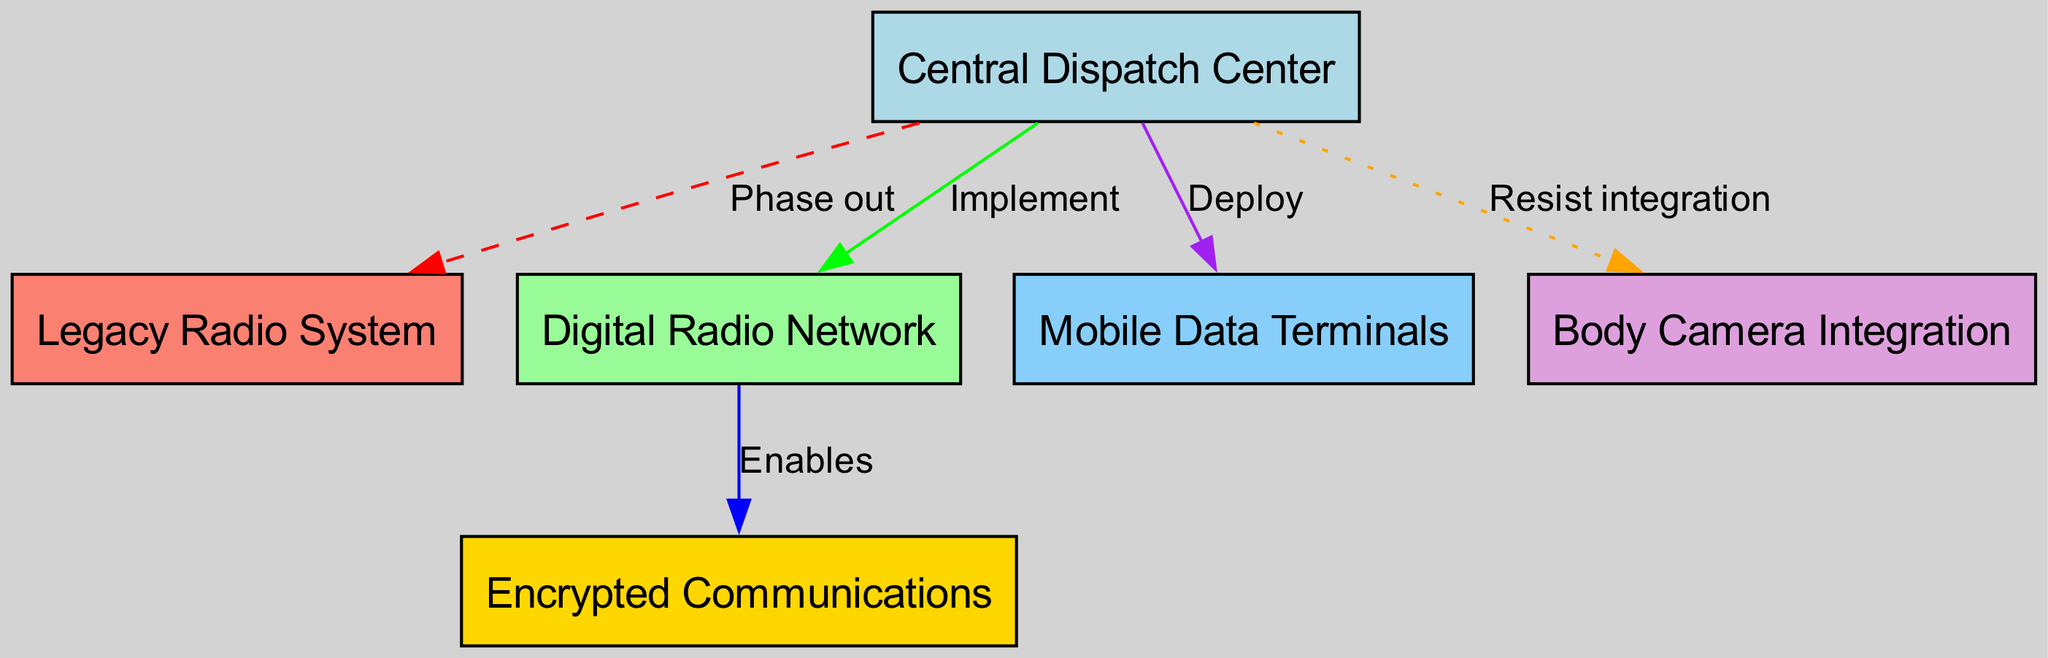What is the label of the node from the dispatch center that is being phased out? The diagram indicates that the dispatch center is connected to the legacy radio system, labeled as "Phase out." Thus, the node being phased out is the legacy radio system.
Answer: Legacy Radio System How many nodes are present in the diagram? By counting the nodes listed in the diagram, we find there are a total of six nodes: Central Dispatch Center, Legacy Radio System, Digital Radio Network, Encrypted Communications, Mobile Data Terminals, and Body Camera Integration.
Answer: 6 What is the relationship between the digital radio and encrypted communications? The diagram shows an edge labeled "Enables" directly connecting the digital radio network to encrypted communications, indicating that the digital radio network enables the encrypted communications.
Answer: Enables What is the primary action taken with the mobile data terminals? The action taken regarding the mobile data terminals, as indicated by the edge from the dispatch center, is labeled "Deploy." Therefore, the primary action is to deploy the mobile data terminals.
Answer: Deploy Which system is indicated to have resistance towards integration? The diagram specifies a connection from the dispatch center to body camera integration labeled "Resist integration," indicating the system that is facing resistance is the body camera integration.
Answer: Body Camera Integration What color represents the digital radio network in the diagram? Looking at the node colors described, the digital radio network is represented in pale green.
Answer: Pale Green How many edges are in the diagram? By examining the edges detailed in the diagram, there are five connections in total: phase out to legacy radio, implement to digital radio, enables to encrypted communications, deploy to mobile data, and resist integration to body cams.
Answer: 5 Which node is directly connected to both the digital radio network and mobile data terminals? The dispatch center is the only node that directly connects to the digital radio network (through "Implement") and the mobile data terminals (through "Deploy").
Answer: Central Dispatch Center What is the significance of the edge labeled "Phase out"? This edge indicates that the legacy radio system will be withdrawn, signifying a planned obsolescence or removal as part of the communication system upgrade strategy.
Answer: Phase out 